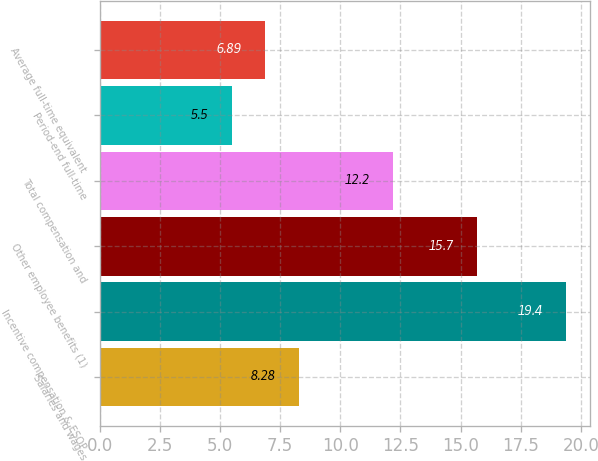Convert chart to OTSL. <chart><loc_0><loc_0><loc_500><loc_500><bar_chart><fcel>Salaries and wages<fcel>Incentive compensation & ESOP<fcel>Other employee benefits (1)<fcel>Total compensation and<fcel>Period-end full-time<fcel>Average full-time equivalent<nl><fcel>8.28<fcel>19.4<fcel>15.7<fcel>12.2<fcel>5.5<fcel>6.89<nl></chart> 